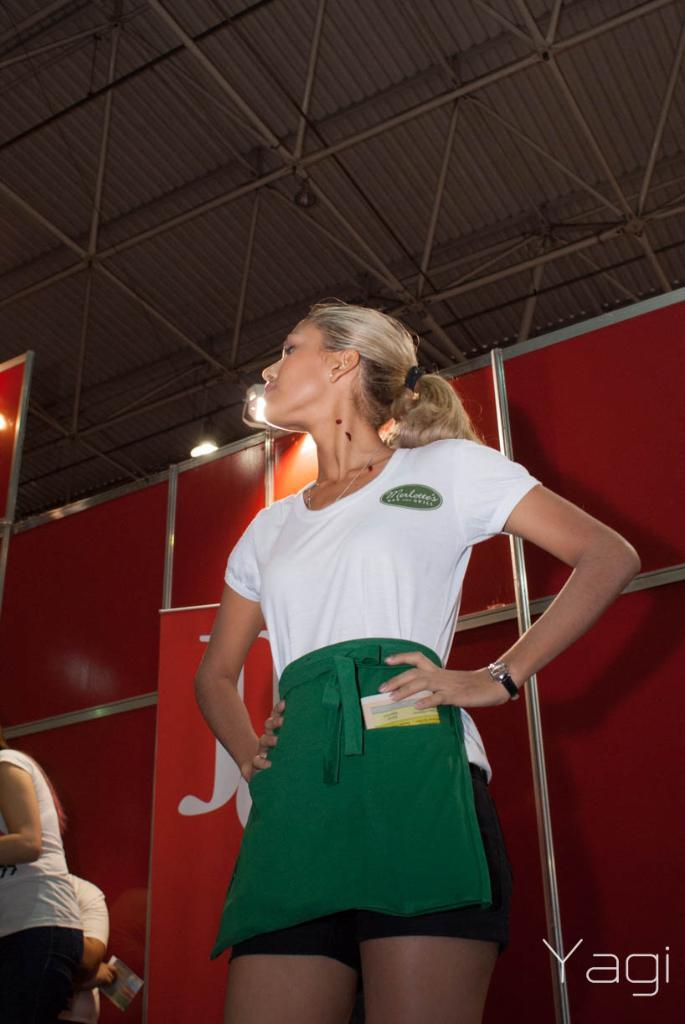What can be seen in the image? There are people in the image. What is visible in the background of the image? There are boards, a wall, a roof, and lights in the background of the image. Is there any text present in the image? Yes, there is some text in the bottom right corner of the image. Can you tell me how many sheep are present in the image? There are no sheep present in the image. What type of wheel can be seen in the image? There is no wheel present in the image. 